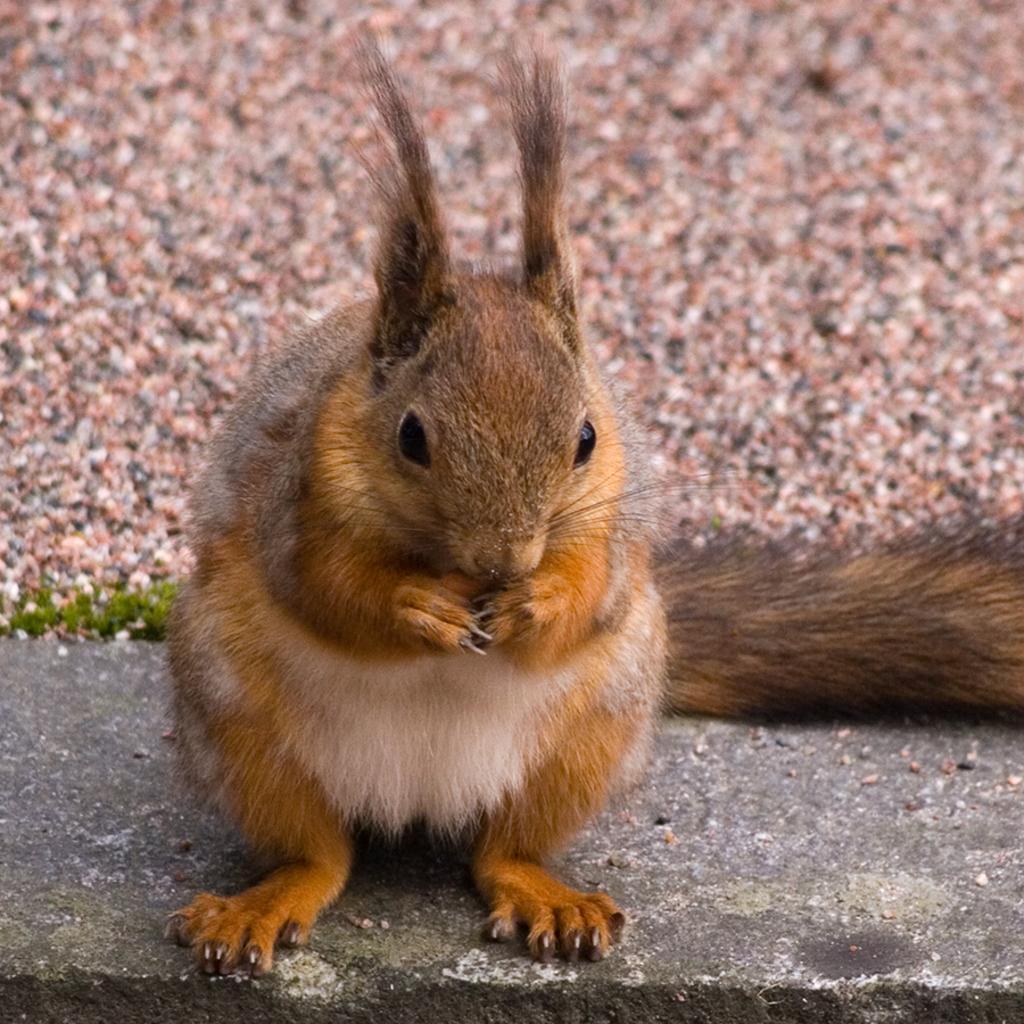How would you summarize this image in a sentence or two? In this picture we can see a squirrel on the wall. 